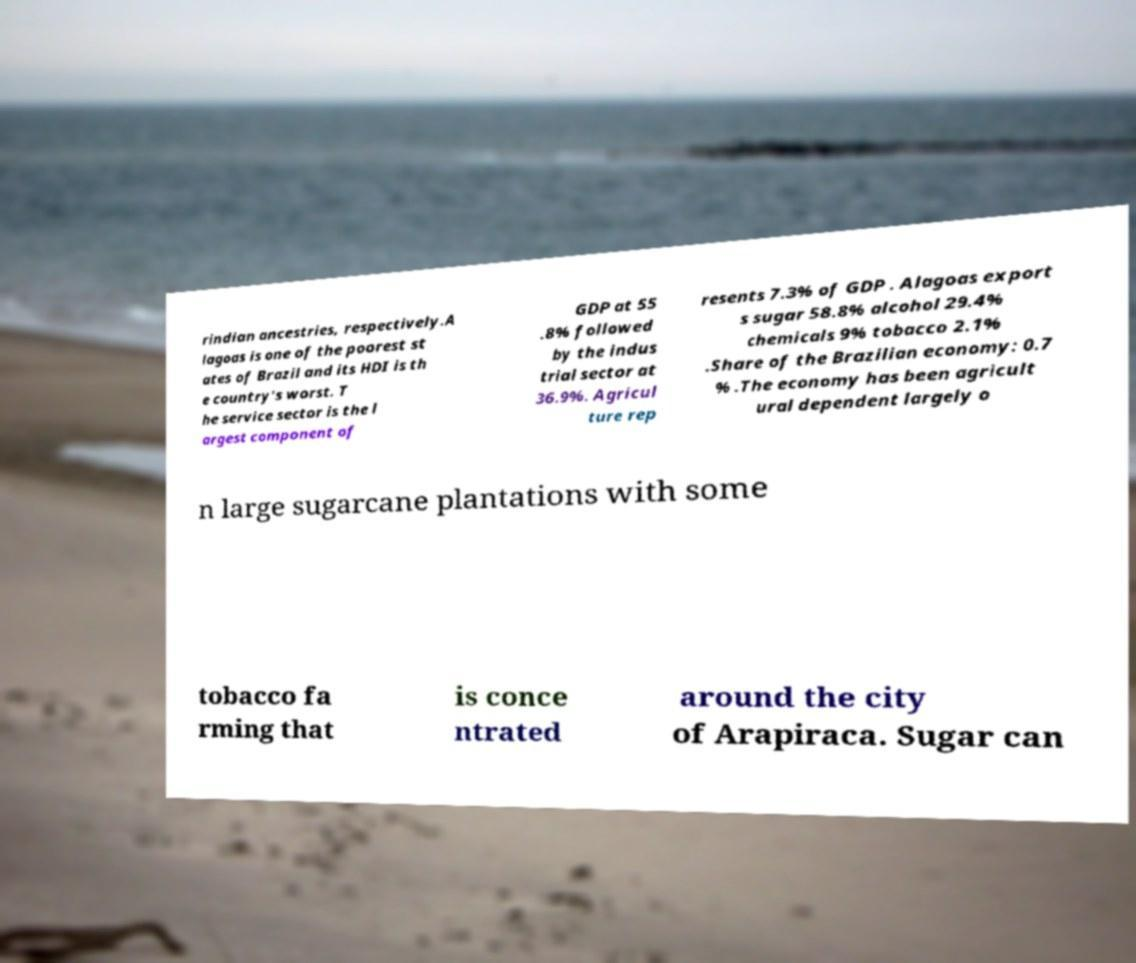Please read and relay the text visible in this image. What does it say? rindian ancestries, respectively.A lagoas is one of the poorest st ates of Brazil and its HDI is th e country's worst. T he service sector is the l argest component of GDP at 55 .8% followed by the indus trial sector at 36.9%. Agricul ture rep resents 7.3% of GDP . Alagoas export s sugar 58.8% alcohol 29.4% chemicals 9% tobacco 2.1% .Share of the Brazilian economy: 0.7 % .The economy has been agricult ural dependent largely o n large sugarcane plantations with some tobacco fa rming that is conce ntrated around the city of Arapiraca. Sugar can 